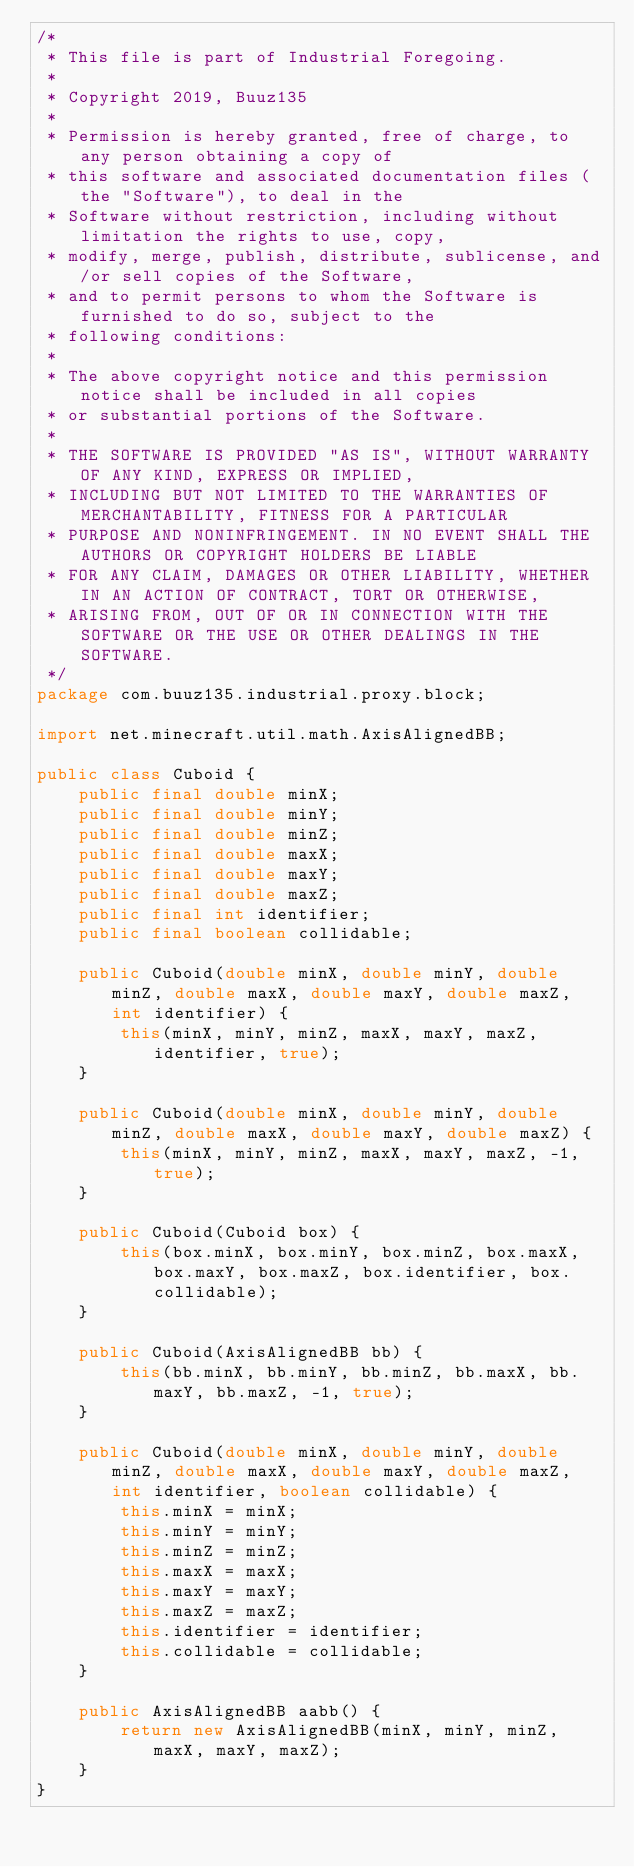<code> <loc_0><loc_0><loc_500><loc_500><_Java_>/*
 * This file is part of Industrial Foregoing.
 *
 * Copyright 2019, Buuz135
 *
 * Permission is hereby granted, free of charge, to any person obtaining a copy of
 * this software and associated documentation files (the "Software"), to deal in the
 * Software without restriction, including without limitation the rights to use, copy,
 * modify, merge, publish, distribute, sublicense, and/or sell copies of the Software,
 * and to permit persons to whom the Software is furnished to do so, subject to the
 * following conditions:
 *
 * The above copyright notice and this permission notice shall be included in all copies
 * or substantial portions of the Software.
 *
 * THE SOFTWARE IS PROVIDED "AS IS", WITHOUT WARRANTY OF ANY KIND, EXPRESS OR IMPLIED,
 * INCLUDING BUT NOT LIMITED TO THE WARRANTIES OF MERCHANTABILITY, FITNESS FOR A PARTICULAR
 * PURPOSE AND NONINFRINGEMENT. IN NO EVENT SHALL THE AUTHORS OR COPYRIGHT HOLDERS BE LIABLE
 * FOR ANY CLAIM, DAMAGES OR OTHER LIABILITY, WHETHER IN AN ACTION OF CONTRACT, TORT OR OTHERWISE,
 * ARISING FROM, OUT OF OR IN CONNECTION WITH THE SOFTWARE OR THE USE OR OTHER DEALINGS IN THE SOFTWARE.
 */
package com.buuz135.industrial.proxy.block;

import net.minecraft.util.math.AxisAlignedBB;

public class Cuboid {
    public final double minX;
    public final double minY;
    public final double minZ;
    public final double maxX;
    public final double maxY;
    public final double maxZ;
    public final int identifier;
    public final boolean collidable;

    public Cuboid(double minX, double minY, double minZ, double maxX, double maxY, double maxZ, int identifier) {
        this(minX, minY, minZ, maxX, maxY, maxZ, identifier, true);
    }

    public Cuboid(double minX, double minY, double minZ, double maxX, double maxY, double maxZ) {
        this(minX, minY, minZ, maxX, maxY, maxZ, -1, true);
    }

    public Cuboid(Cuboid box) {
        this(box.minX, box.minY, box.minZ, box.maxX, box.maxY, box.maxZ, box.identifier, box.collidable);
    }

    public Cuboid(AxisAlignedBB bb) {
        this(bb.minX, bb.minY, bb.minZ, bb.maxX, bb.maxY, bb.maxZ, -1, true);
    }

    public Cuboid(double minX, double minY, double minZ, double maxX, double maxY, double maxZ, int identifier, boolean collidable) {
        this.minX = minX;
        this.minY = minY;
        this.minZ = minZ;
        this.maxX = maxX;
        this.maxY = maxY;
        this.maxZ = maxZ;
        this.identifier = identifier;
        this.collidable = collidable;
    }

    public AxisAlignedBB aabb() {
        return new AxisAlignedBB(minX, minY, minZ, maxX, maxY, maxZ);
    }
}</code> 